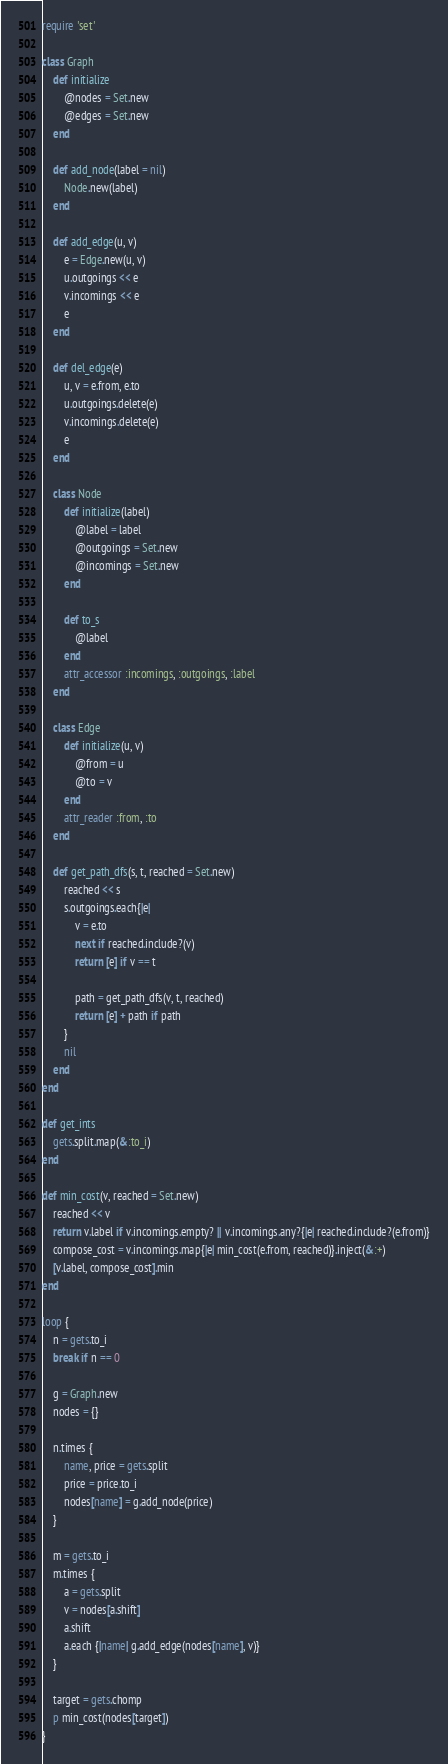Convert code to text. <code><loc_0><loc_0><loc_500><loc_500><_Ruby_>require 'set'

class Graph
	def initialize
		@nodes = Set.new
		@edges = Set.new
	end

	def add_node(label = nil)
		Node.new(label)
	end

	def add_edge(u, v)
		e = Edge.new(u, v)
		u.outgoings << e
		v.incomings << e
		e
	end
	
	def del_edge(e)
		u, v = e.from, e.to
		u.outgoings.delete(e)
		v.incomings.delete(e)
		e
	end

	class Node
		def initialize(label)
			@label = label
			@outgoings = Set.new
			@incomings = Set.new
		end
		
		def to_s
			@label
		end
		attr_accessor :incomings, :outgoings, :label
	end

	class Edge
		def initialize(u, v)
			@from = u	
			@to = v
		end
		attr_reader :from, :to
	end

	def get_path_dfs(s, t, reached = Set.new)
		reached << s	
		s.outgoings.each{|e|
			v = e.to
			next if reached.include?(v)
			return [e] if v == t
			
			path = get_path_dfs(v, t, reached) 
			return [e] + path if path
		}
		nil
	end
end

def get_ints
	gets.split.map(&:to_i)
end

def min_cost(v, reached = Set.new)
	reached << v
	return v.label if v.incomings.empty? || v.incomings.any?{|e| reached.include?(e.from)}
	compose_cost = v.incomings.map{|e| min_cost(e.from, reached)}.inject(&:+)
	[v.label, compose_cost].min
end

loop {
	n = gets.to_i
	break if n == 0

	g = Graph.new
	nodes = {}

	n.times {
		name, price = gets.split
		price = price.to_i
		nodes[name] = g.add_node(price)
	}

	m = gets.to_i
	m.times {
		a = gets.split
		v = nodes[a.shift]
		a.shift
		a.each {|name| g.add_edge(nodes[name], v)}
	}

	target = gets.chomp
	p min_cost(nodes[target])
}</code> 